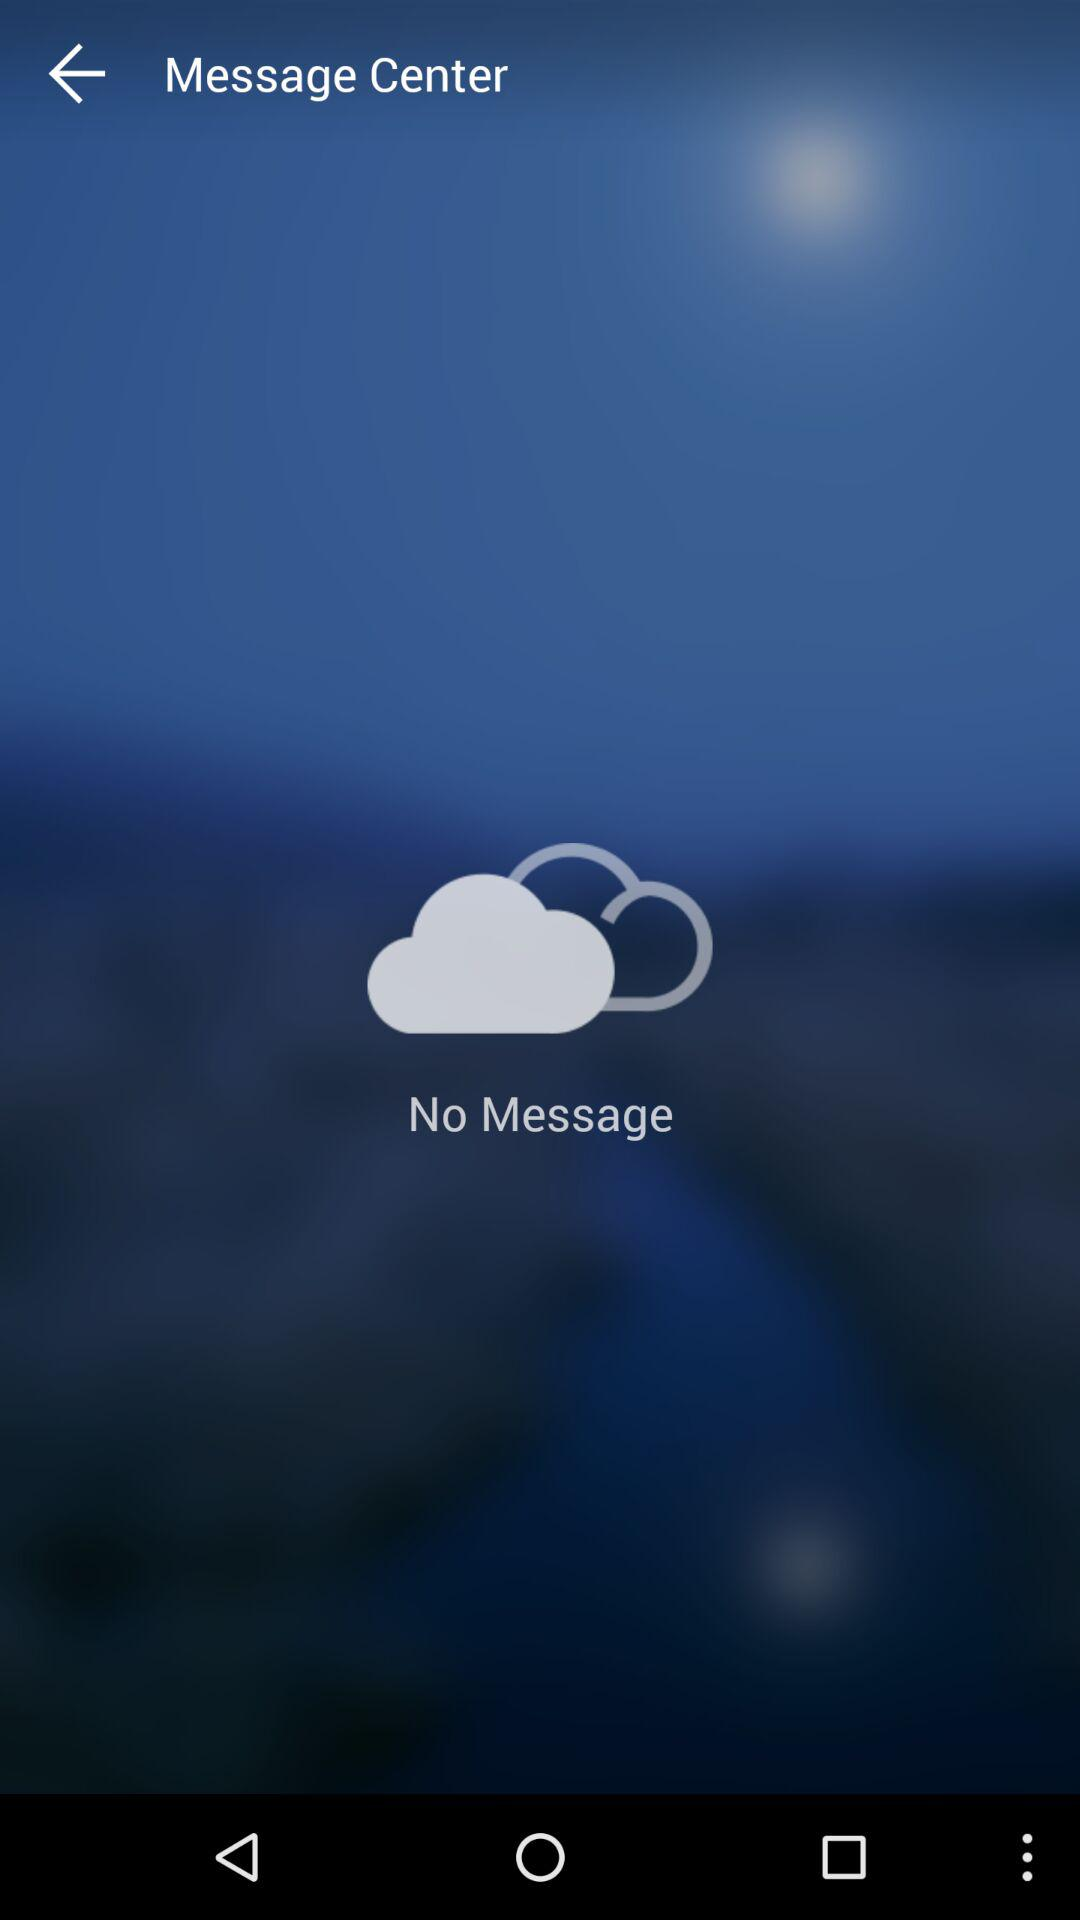How many messages in total are received? There are no messages received. 